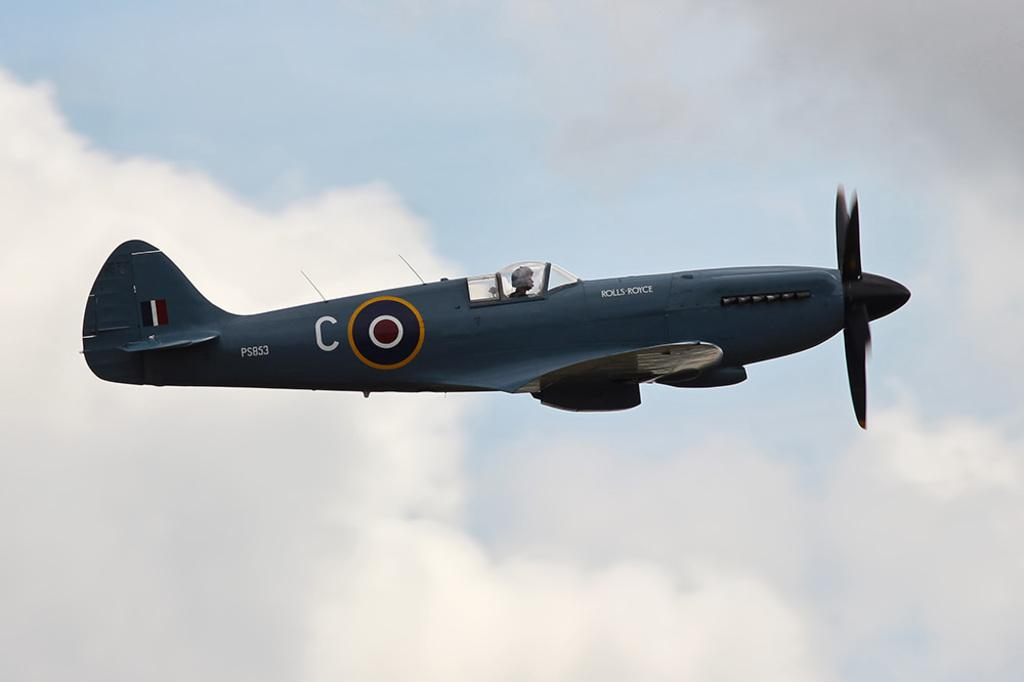<image>
Render a clear and concise summary of the photo. A world war 2 plane flies with PS853 markings near the tail 